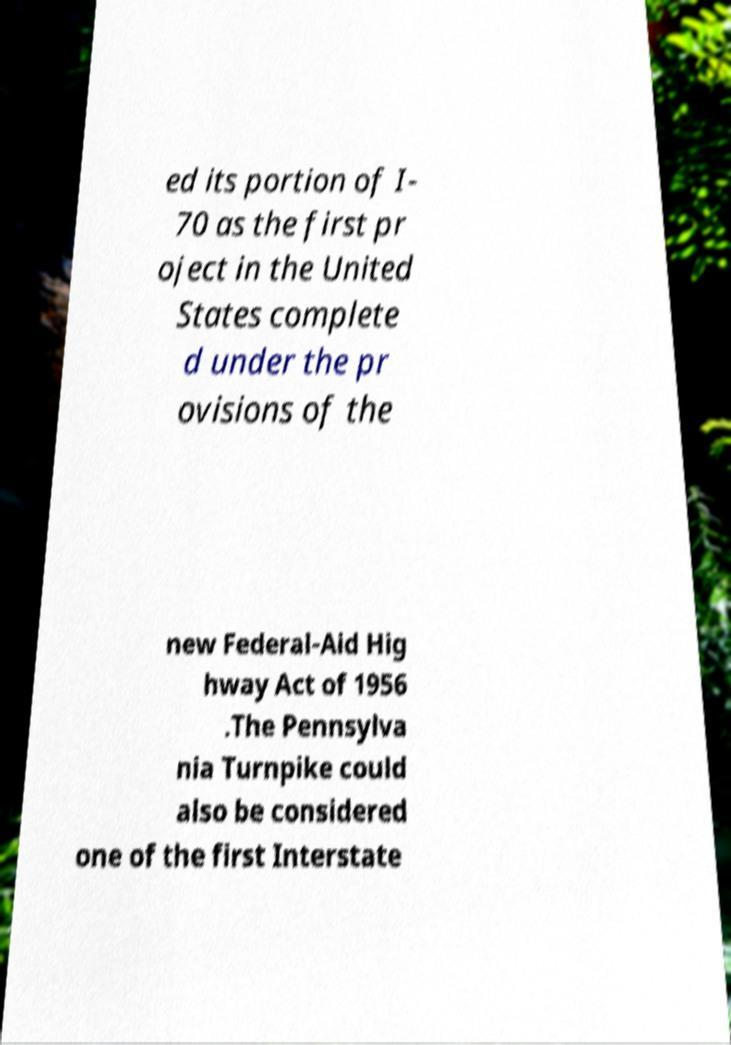Can you accurately transcribe the text from the provided image for me? ed its portion of I- 70 as the first pr oject in the United States complete d under the pr ovisions of the new Federal-Aid Hig hway Act of 1956 .The Pennsylva nia Turnpike could also be considered one of the first Interstate 